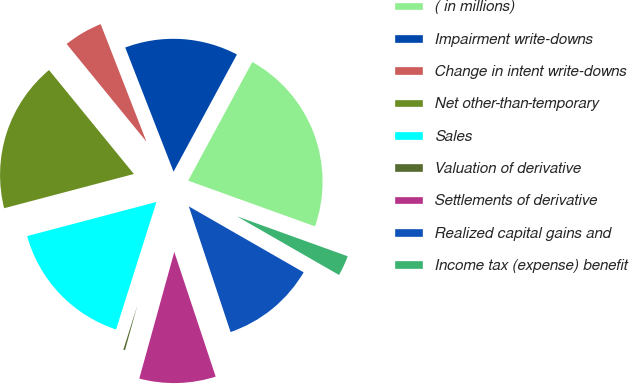Convert chart to OTSL. <chart><loc_0><loc_0><loc_500><loc_500><pie_chart><fcel>( in millions)<fcel>Impairment write-downs<fcel>Change in intent write-downs<fcel>Net other-than-temporary<fcel>Sales<fcel>Valuation of derivative<fcel>Settlements of derivative<fcel>Realized capital gains and<fcel>Income tax (expense) benefit<nl><fcel>22.62%<fcel>13.8%<fcel>4.99%<fcel>18.21%<fcel>16.01%<fcel>0.59%<fcel>9.4%<fcel>11.6%<fcel>2.79%<nl></chart> 